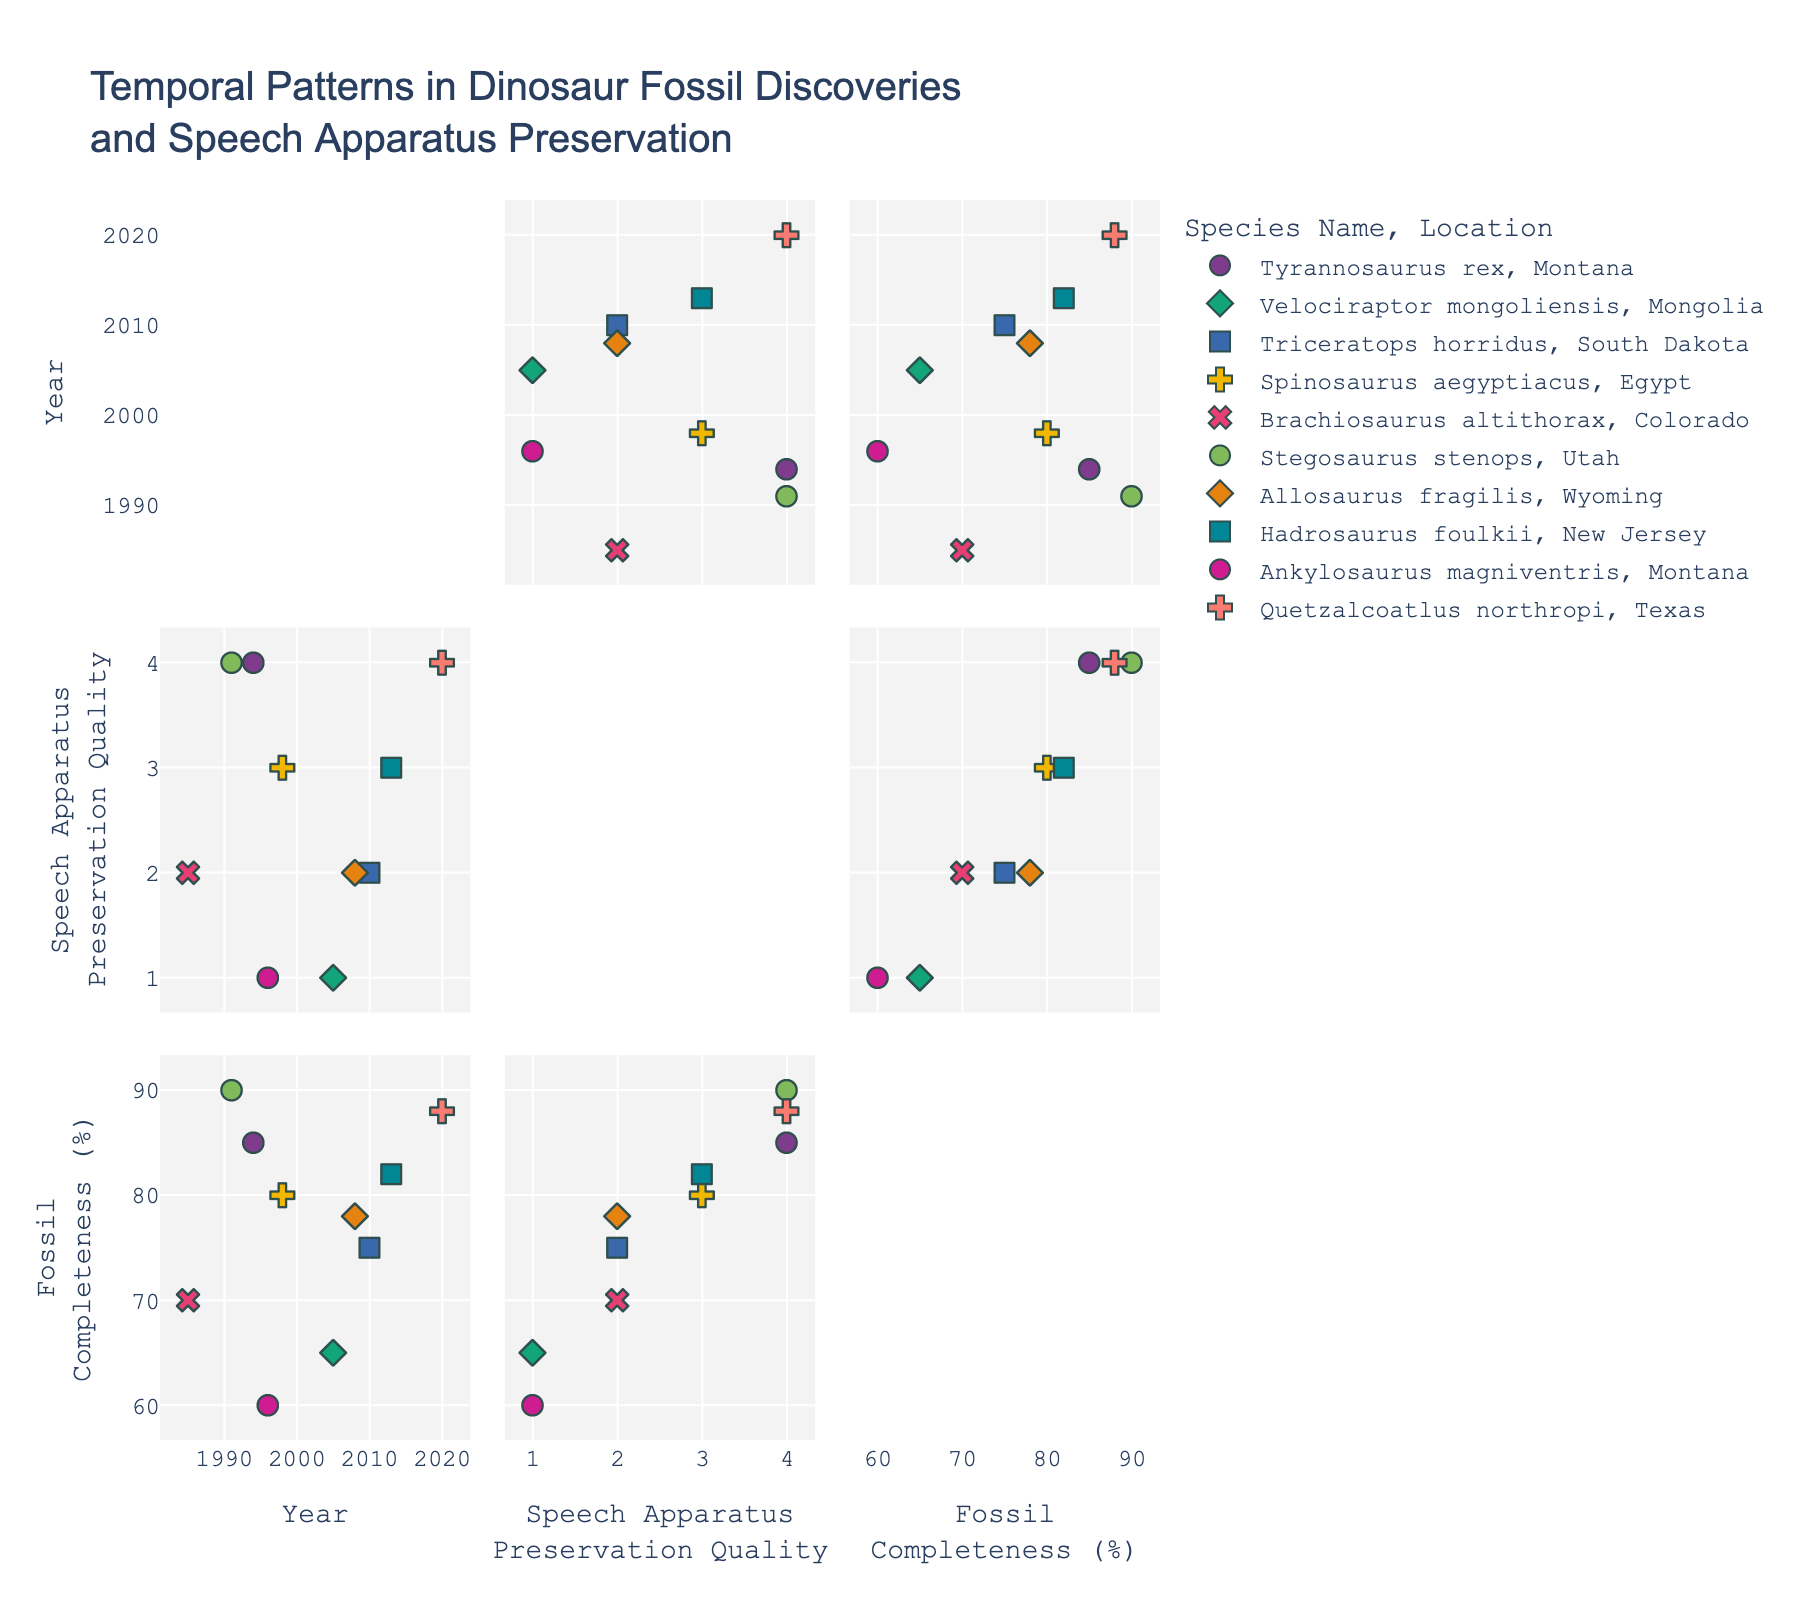What's the title of the Scatter Plot Matrix? The title is usually placed at the top center of the figure.
Answer: Temporal Patterns in Dinosaur Fossil Discoveries and Speech Apparatus Preservation How many dimensions are represented in the Scatter Plot Matrix? Look at each axis to see how many unique variables are plotted. Here, the dimensions are Year, Speech Apparatus Preservation Quality, and Fossil Completeness(%).
Answer: 3 What is the preservation quality score for 'Excellent' speech apparatus preservation quality? Check the legend or axis labels to see what numerical value corresponds to 'Excellent'.
Answer: 4 Which species has the highest fossil completeness percentage? Locate the highest point in the Fossil Completeness(%) axis and check the corresponding data point's Species Name label.
Answer: Stegosaurus stenops Which species were discovered in the year 1994? Locate the column titled 'Year' and find the data points that have a value of 1994. Check the corresponding species for those data points.
Answer: Tyrannosaurus rex What is the most common location symbol in the plot? Check the symbol representation for each Location in the legend and count the occurrences of each symbol type in the data points.
Answer: Montana Compare the fossil completeness of 'Stegosaurus stenops' and 'Ankylosaurus magniventris'. Which one is higher? Locate 'Stegosaurus stenops' and 'Ankylosaurus magniventris' in the plot, check their Fossil Completeness values, and compare them.
Answer: Stegosaurus stenops Is there any correlation between the year of discovery and fossil completeness percentage? Look at the scatter plot matrix block that compares 'Year' with 'Fossil Completeness (%)', and observe how the points are distributed.
Answer: No obvious correlation Which species discovered after 2000 have a good or excellent speech apparatus preservation quality? Filter out the data points with Year > 2000, then check their Speech Apparatus Preservation Quality scores for 'Good' or 'Excellent'. Note the corresponding species.
Answer: Hadrosaurus foulkii, Quetzalcoatlus northropi Is there a trend in the number of discoveries over time? Examine the distribution of data points along the 'Year' axis to see if there are more discoveries in recent years.
Answer: Slight increase 